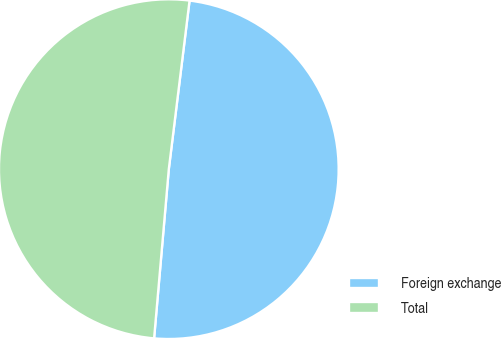Convert chart. <chart><loc_0><loc_0><loc_500><loc_500><pie_chart><fcel>Foreign exchange<fcel>Total<nl><fcel>49.43%<fcel>50.57%<nl></chart> 